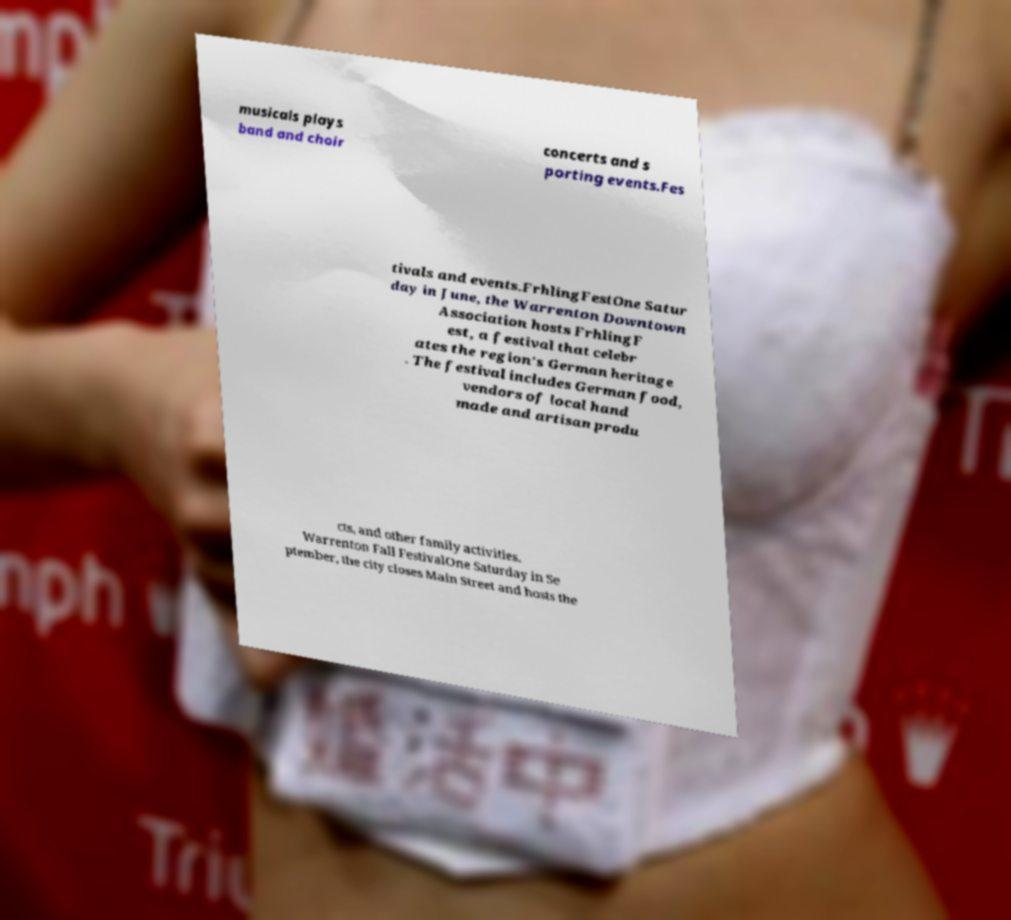Could you extract and type out the text from this image? musicals plays band and choir concerts and s porting events.Fes tivals and events.FrhlingFestOne Satur day in June, the Warrenton Downtown Association hosts FrhlingF est, a festival that celebr ates the region's German heritage . The festival includes German food, vendors of local hand made and artisan produ cts, and other family activities. Warrenton Fall FestivalOne Saturday in Se ptember, the city closes Main Street and hosts the 